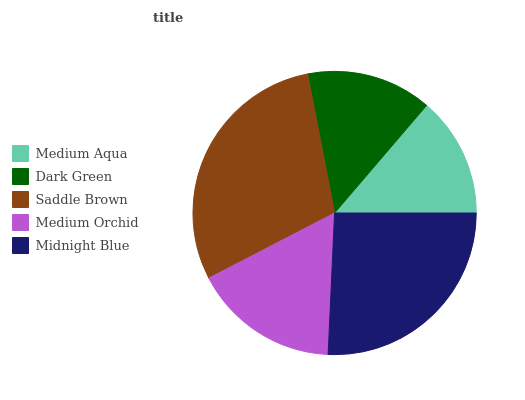Is Medium Aqua the minimum?
Answer yes or no. Yes. Is Saddle Brown the maximum?
Answer yes or no. Yes. Is Dark Green the minimum?
Answer yes or no. No. Is Dark Green the maximum?
Answer yes or no. No. Is Dark Green greater than Medium Aqua?
Answer yes or no. Yes. Is Medium Aqua less than Dark Green?
Answer yes or no. Yes. Is Medium Aqua greater than Dark Green?
Answer yes or no. No. Is Dark Green less than Medium Aqua?
Answer yes or no. No. Is Medium Orchid the high median?
Answer yes or no. Yes. Is Medium Orchid the low median?
Answer yes or no. Yes. Is Medium Aqua the high median?
Answer yes or no. No. Is Saddle Brown the low median?
Answer yes or no. No. 